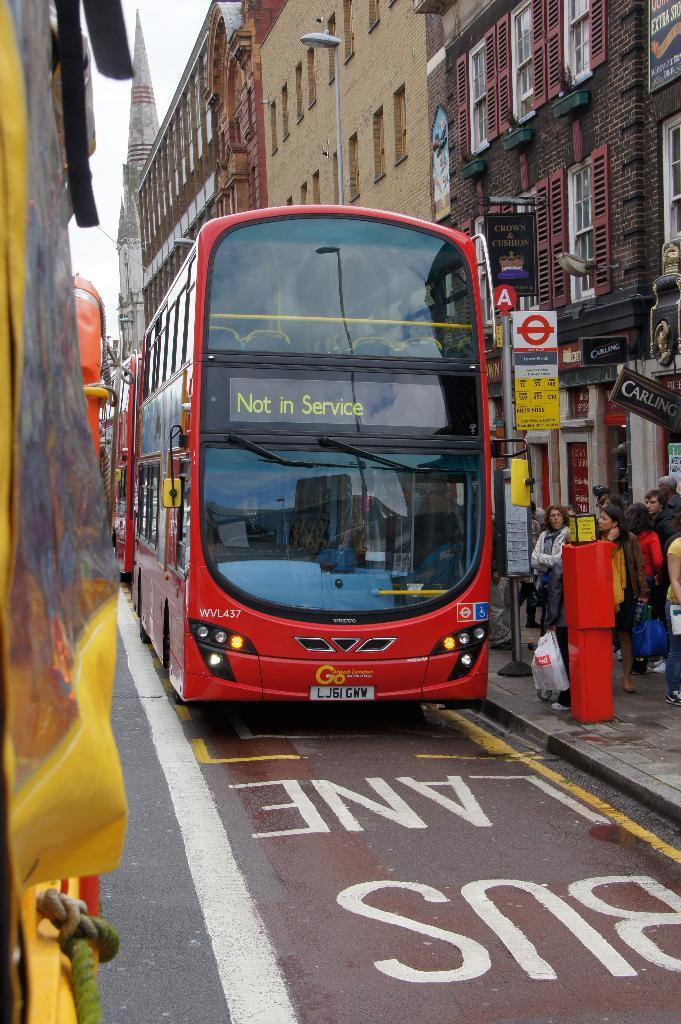What type of vehicle is in the image? There is a red color bus in the image. Where is the bus located? The bus is parked on the road. What can be seen on the right side of the image? There are people standing on the footpath on the right side. What is visible in the background of the image? There is a building and the sky in the background of the image. What type of stage can be seen in the image? There is no stage present in the image. How can the people on the footpath help the bus driver in the image? The image does not show any interaction between the people on the footpath and the bus driver, so it is not possible to determine how they might help. 